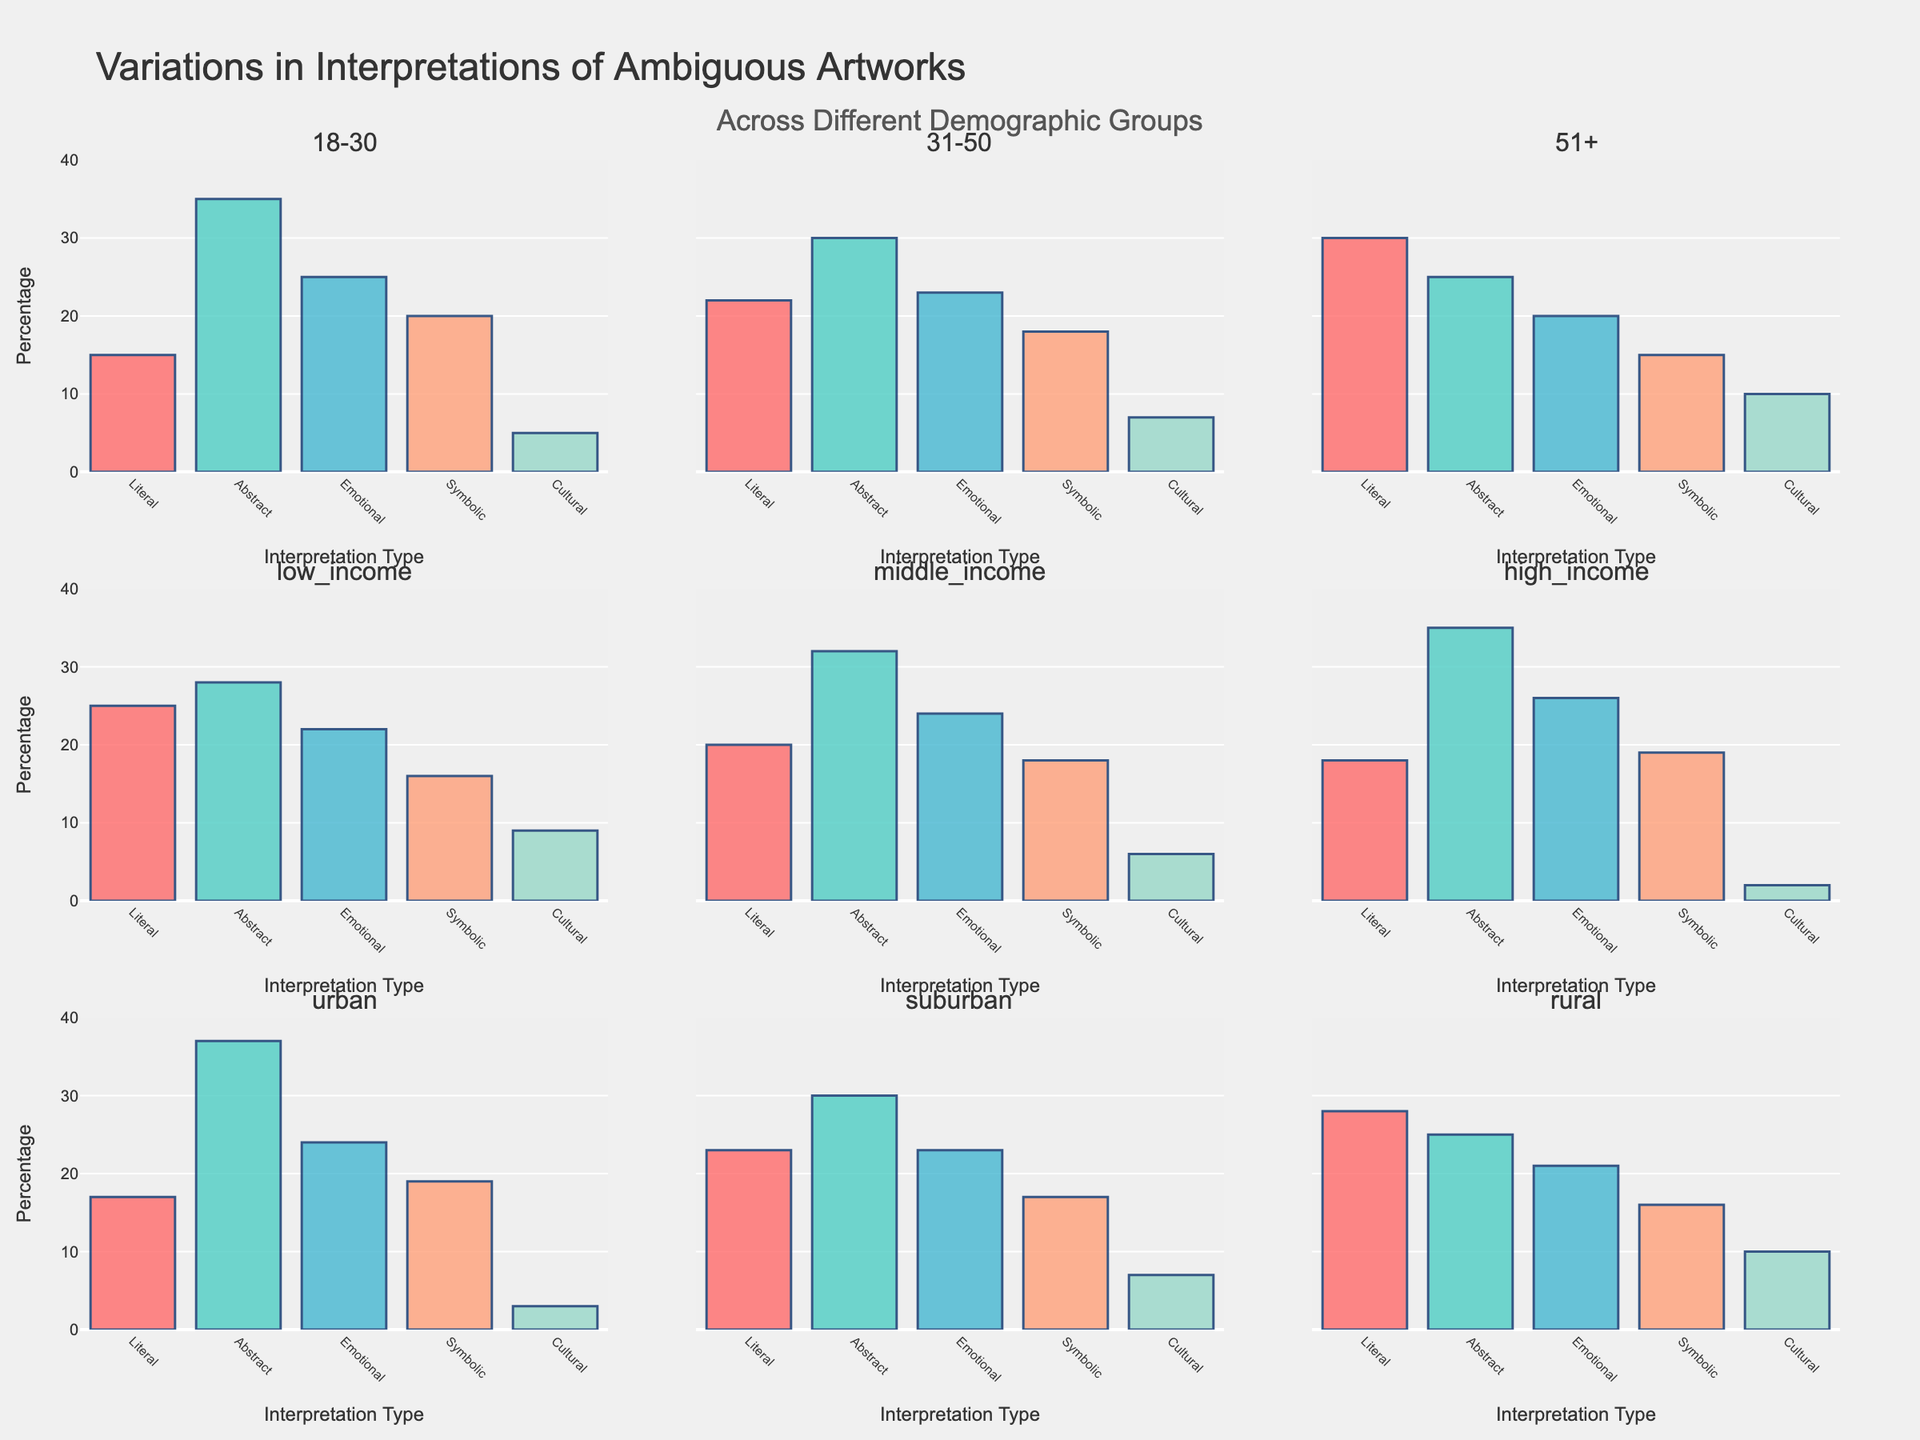Which interpretation type has the highest percentage among the 18-30 age group? Look at the subplot for the 18-30 age group and identify the tallest bar. The longest bar represents the "Abstract" interpretation type.
Answer: Abstract Which demographic group has the lowest percentage for the Cultural interpretation type? Compare the heights of the bars for the "Cultural" interpretation across all demographic subplots. The smallest bar appears in the "high_income" group.
Answer: High Income What is the sum of the percentages for Literal and Abstract interpretations in the suburban group? Add the heights of the Literal and Abstract bars in the "suburban" group: 23 (Literal) + 30 (Abstract) = 53.
Answer: 53 How does the Emotional interpretation type compare between the rural and urban demographics? Look at the heights of the Emotional bars in the "rural" and "urban" subplots. The Emotional bar in the rural area is slightly lower than that in the urban area.
Answer: Lower in Rural What is the average percentage of the Symbolic interpretation type across all age groups (18-30, 31-50, 51+)? Add the Symbolic percentages for the age groups and divide by the number of groups: (20 + 18 + 15) / 3 = 53 / 3 = 17.67.
Answer: 17.67 Which demographic group has the widest range of interpretation types, and how can you tell? Identify the group with the most significant difference between the highest and lowest bar values in the same subplot. This is the "low_income" group, with Abstract being the highest (28) and Cultural being the lowest (16).
Answer: Low Income What is the visual difference in the bars representing Literal interpretations for the 31-50 and 51+ age groups? Compare the heights of the Literal bars in the 31-50 and 51+ subplots visually. The Literal bar in the 51+ group is taller than the one in the 31-50 group.
Answer: Taller in 51+ How do the Cultural interpretation values compare between urban and rural areas? Compare the heights of the Cultural bars in the "urban" and "rural" subplots. The bar in the rural area is taller than that in the urban area.
Answer: Higher in Rural 